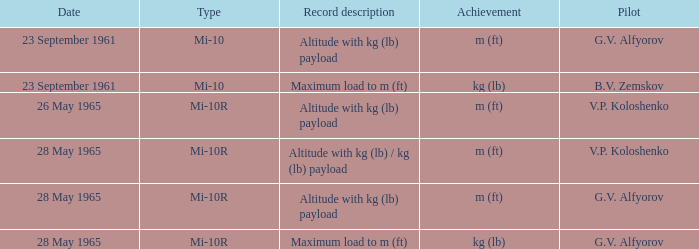Identify the pilot who achieved a maximum load of m (ft) on 23rd september 1961. B.V. Zemskov. 